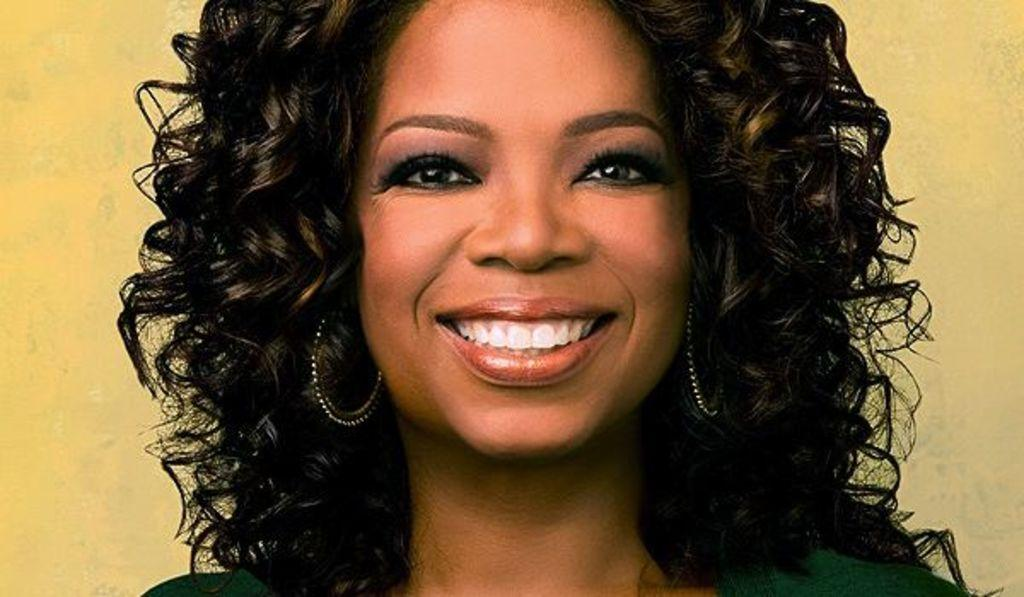Who is present in the image? There is a lady in the image. What expression does the lady have? The lady is smiling. What type of accessory is the lady wearing? The lady is wearing earrings. What type of sail can be seen on the lady's clothing in the image? There is no sail present on the lady's clothing in the image. What type of porter is assisting the lady in the image? There is no porter present in the image. 